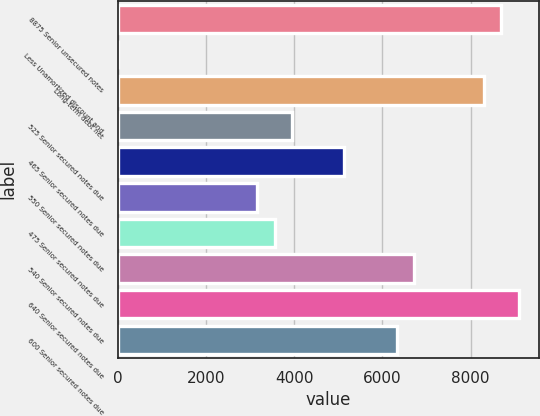Convert chart to OTSL. <chart><loc_0><loc_0><loc_500><loc_500><bar_chart><fcel>8875 Senior unsecured notes<fcel>Less Unamortized discount and<fcel>Long-term debt net<fcel>525 Senior secured notes due<fcel>465 Senior secured notes due<fcel>550 Senior secured notes due<fcel>475 Senior secured notes due<fcel>540 Senior secured notes due<fcel>640 Senior secured notes due<fcel>600 Senior secured notes due<nl><fcel>8699.8<fcel>1<fcel>8304.4<fcel>3955<fcel>5141.2<fcel>3164.2<fcel>3559.6<fcel>6722.8<fcel>9095.2<fcel>6327.4<nl></chart> 